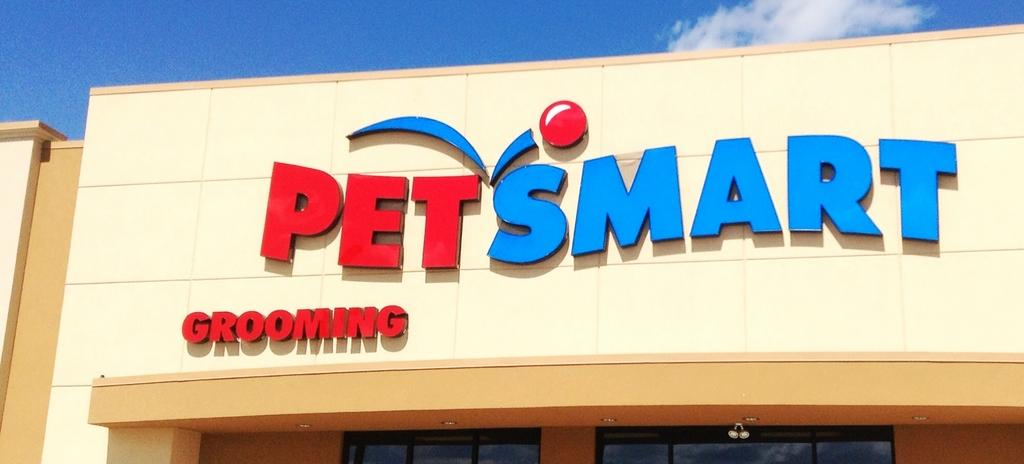What is written or displayed on the wall of the building in the image? There is text on the wall of a building in the image. What architectural features can be seen on the building? The building has windows. What is visible at the top of the image? The sky is visible at the top of the image. What can be observed in the sky? There are clouds in the sky. Where is the scarecrow located in the image? There is no scarecrow present in the image. What type of root can be seen growing from the building in the image? There are no roots visible in the image; it features a building with text on the wall, windows, and a sky with clouds. 